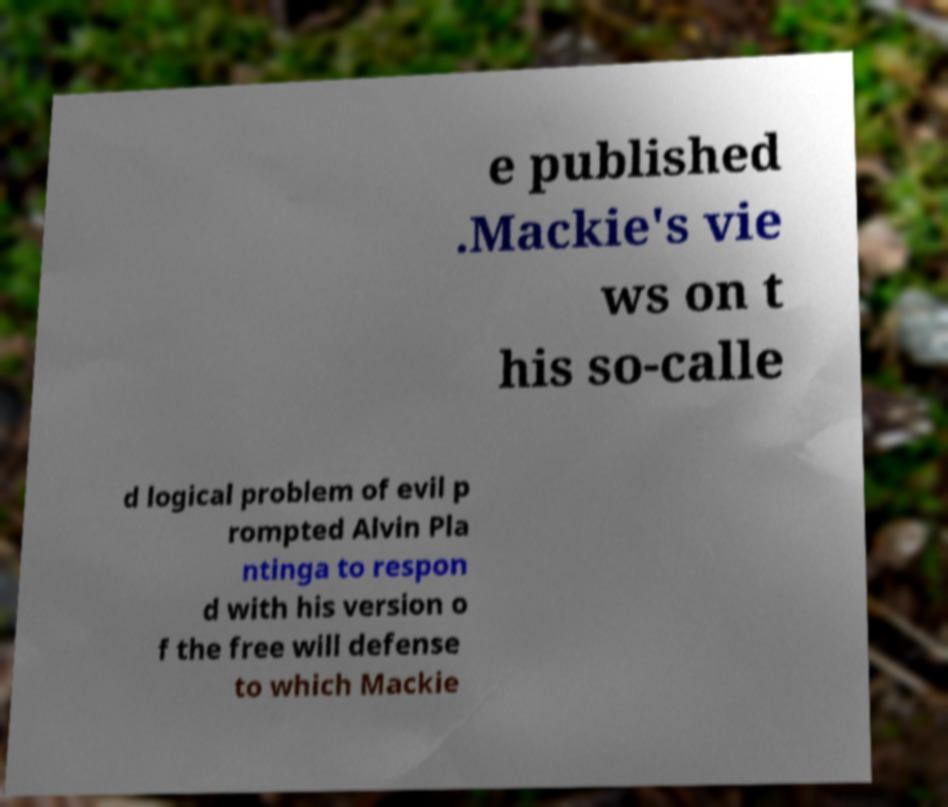Can you read and provide the text displayed in the image?This photo seems to have some interesting text. Can you extract and type it out for me? e published .Mackie's vie ws on t his so-calle d logical problem of evil p rompted Alvin Pla ntinga to respon d with his version o f the free will defense to which Mackie 